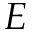Convert formula to latex. <formula><loc_0><loc_0><loc_500><loc_500>E</formula> 